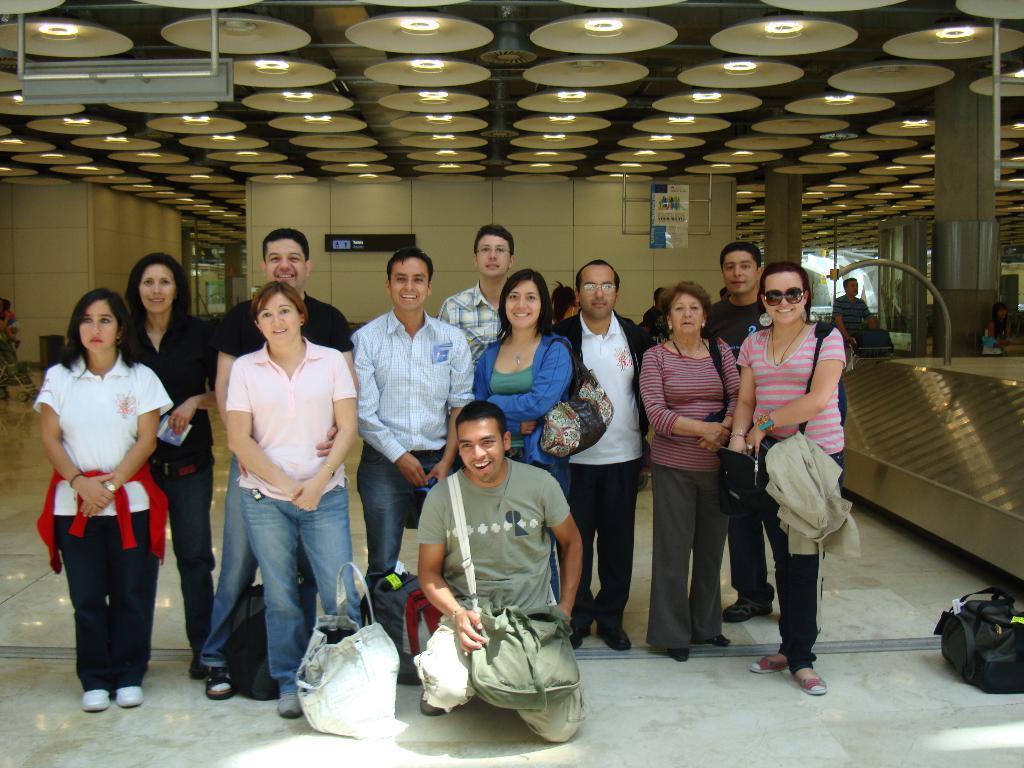In one or two sentences, can you explain what this image depicts? In this image we can see people standing. At the bottom there is a man sitting. There are bags placed on the floor. On the right there is a table. In the background there is a wall. At the top there are lights and we can see pillars. On the left there is a trolley. 